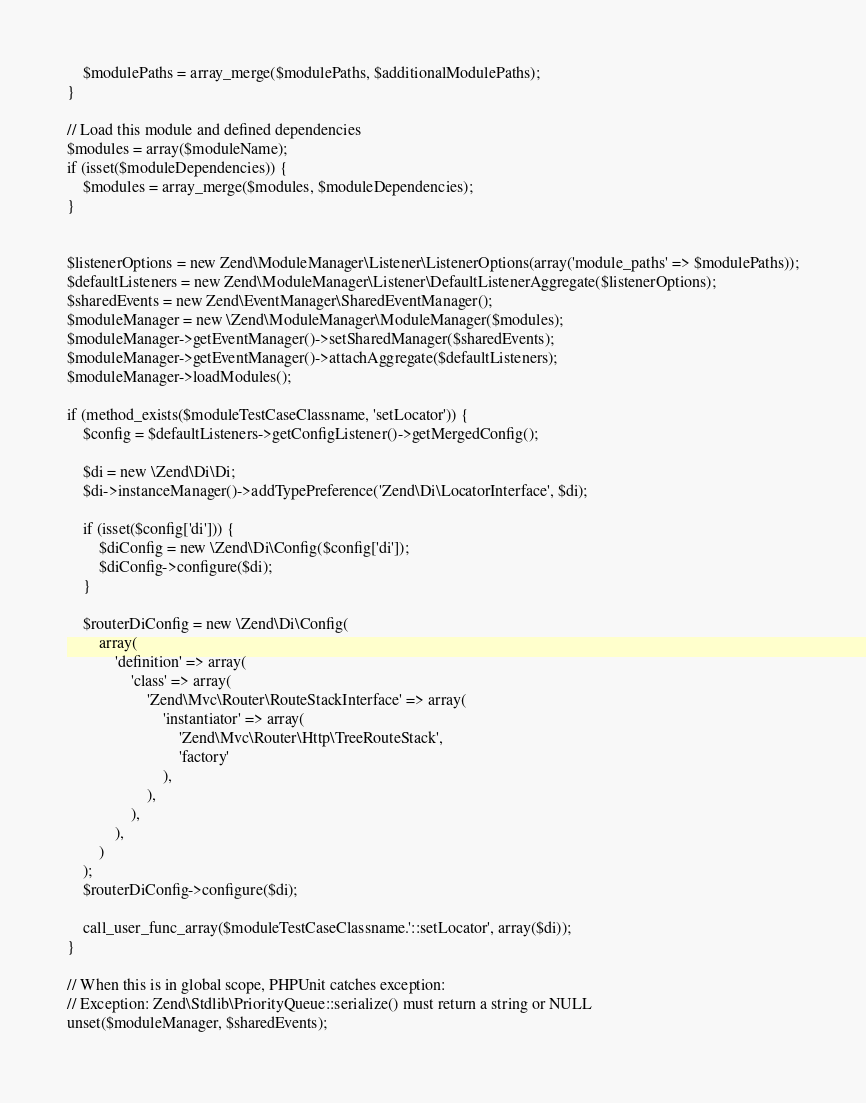Convert code to text. <code><loc_0><loc_0><loc_500><loc_500><_PHP_>    $modulePaths = array_merge($modulePaths, $additionalModulePaths);
}

// Load this module and defined dependencies
$modules = array($moduleName);
if (isset($moduleDependencies)) {
    $modules = array_merge($modules, $moduleDependencies);
}


$listenerOptions = new Zend\ModuleManager\Listener\ListenerOptions(array('module_paths' => $modulePaths));
$defaultListeners = new Zend\ModuleManager\Listener\DefaultListenerAggregate($listenerOptions);
$sharedEvents = new Zend\EventManager\SharedEventManager();
$moduleManager = new \Zend\ModuleManager\ModuleManager($modules);
$moduleManager->getEventManager()->setSharedManager($sharedEvents);
$moduleManager->getEventManager()->attachAggregate($defaultListeners);
$moduleManager->loadModules();

if (method_exists($moduleTestCaseClassname, 'setLocator')) {
    $config = $defaultListeners->getConfigListener()->getMergedConfig();

    $di = new \Zend\Di\Di;
    $di->instanceManager()->addTypePreference('Zend\Di\LocatorInterface', $di);

    if (isset($config['di'])) {
        $diConfig = new \Zend\Di\Config($config['di']);
        $diConfig->configure($di);
    }

    $routerDiConfig = new \Zend\Di\Config(
        array(
            'definition' => array(
                'class' => array(
                    'Zend\Mvc\Router\RouteStackInterface' => array(
                        'instantiator' => array(
                            'Zend\Mvc\Router\Http\TreeRouteStack',
                            'factory'
                        ),
                    ),
                ),
            ),
        )
    );
    $routerDiConfig->configure($di);

    call_user_func_array($moduleTestCaseClassname.'::setLocator', array($di));
}

// When this is in global scope, PHPUnit catches exception:
// Exception: Zend\Stdlib\PriorityQueue::serialize() must return a string or NULL
unset($moduleManager, $sharedEvents);
</code> 